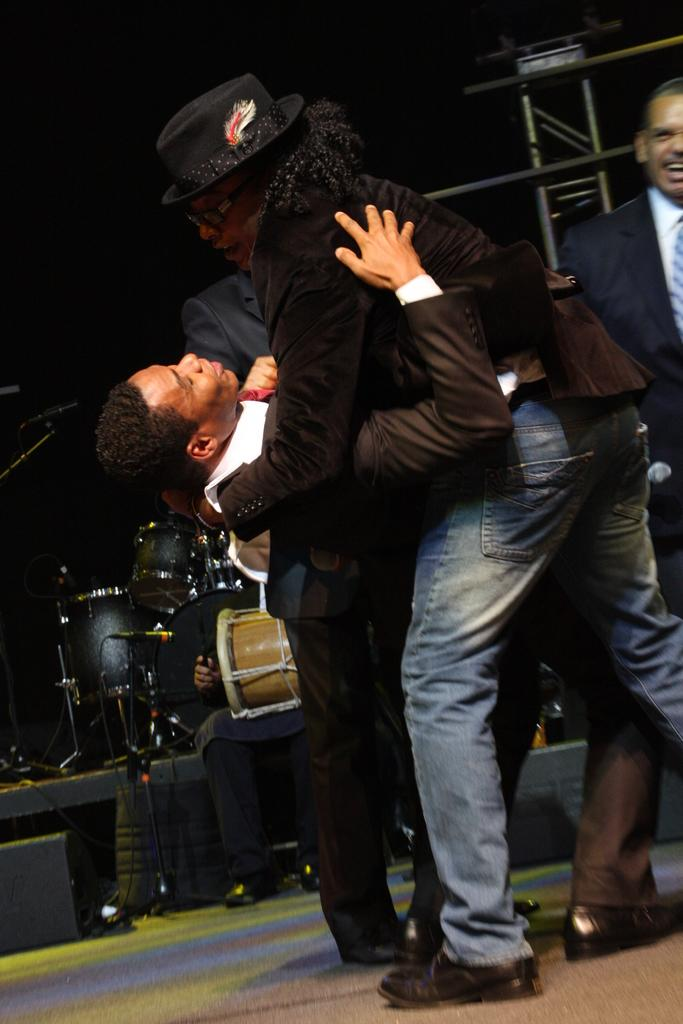How many men are standing on the dais in the image? There are four men standing on a dais in the image. What is the position of the person in the image? There is bending backward. What type of plough is being used by the birds in the image? There are no birds or ploughs present in the image. What color is the ink used by the person bending backward in the image? The person bending backward is not using ink in the image. 